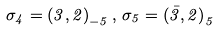Convert formula to latex. <formula><loc_0><loc_0><loc_500><loc_500>\sigma _ { 4 } = { ( 3 , 2 ) } _ { - 5 } \, , \, \sigma _ { 5 } = { ( \bar { 3 } , 2 ) } _ { 5 }</formula> 